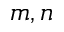<formula> <loc_0><loc_0><loc_500><loc_500>m , n</formula> 